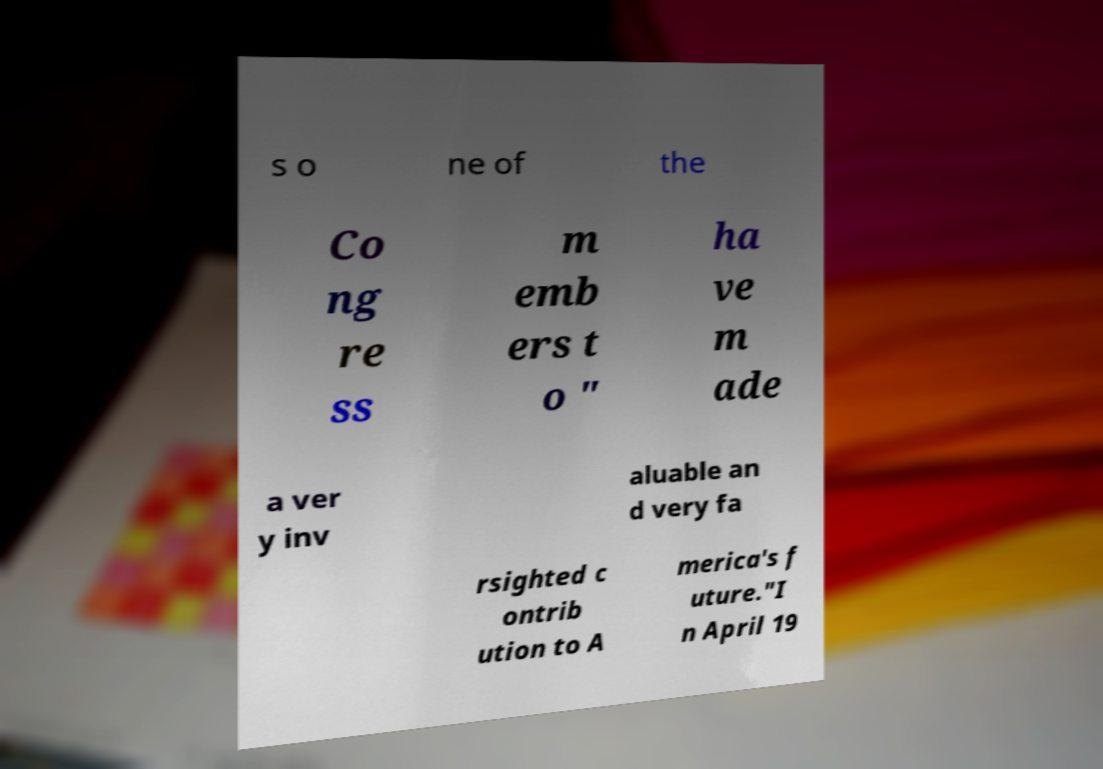Please identify and transcribe the text found in this image. s o ne of the Co ng re ss m emb ers t o " ha ve m ade a ver y inv aluable an d very fa rsighted c ontrib ution to A merica's f uture."I n April 19 